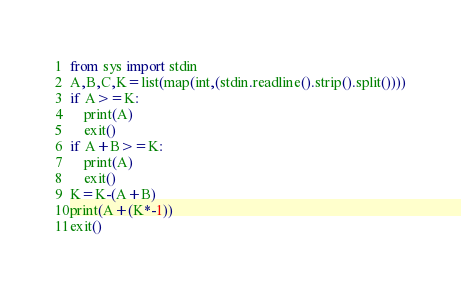Convert code to text. <code><loc_0><loc_0><loc_500><loc_500><_Python_>from sys import stdin
A,B,C,K=list(map(int,(stdin.readline().strip().split())))
if A>=K:
    print(A)
    exit()
if A+B>=K:
    print(A)
    exit()
K=K-(A+B)
print(A+(K*-1))
exit()</code> 